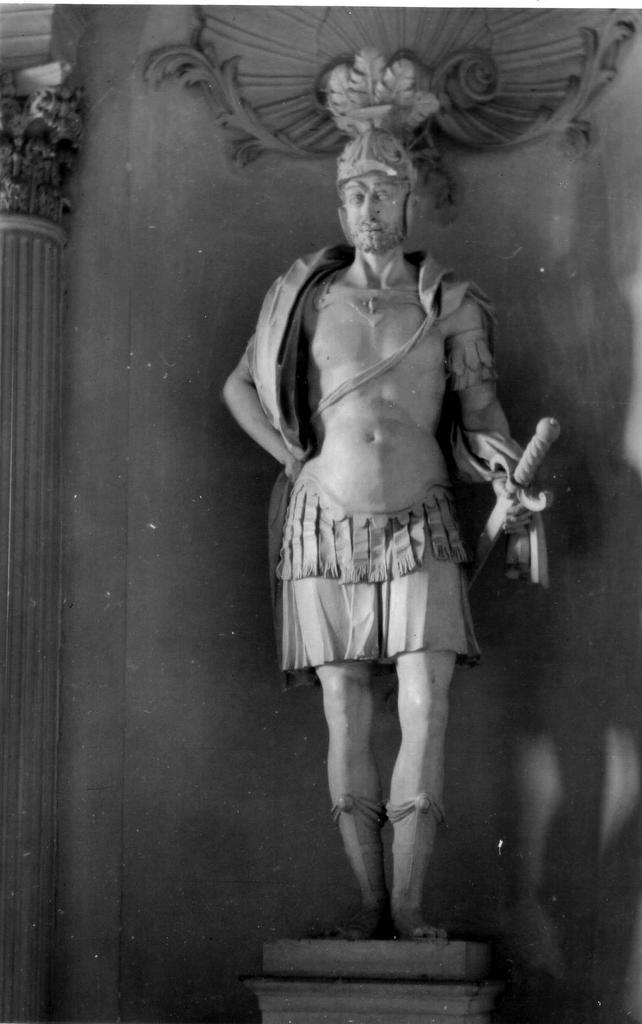What is the color scheme of the image? The image is black and white. What is the main subject in the image? There is a statue in the image. What additional details can be seen on the statue? There are carvings in the image. What type of paper is being used to make adjustments to the statue in the image? There is no paper or adjustments being made to the statue in the image; it is a static representation. 